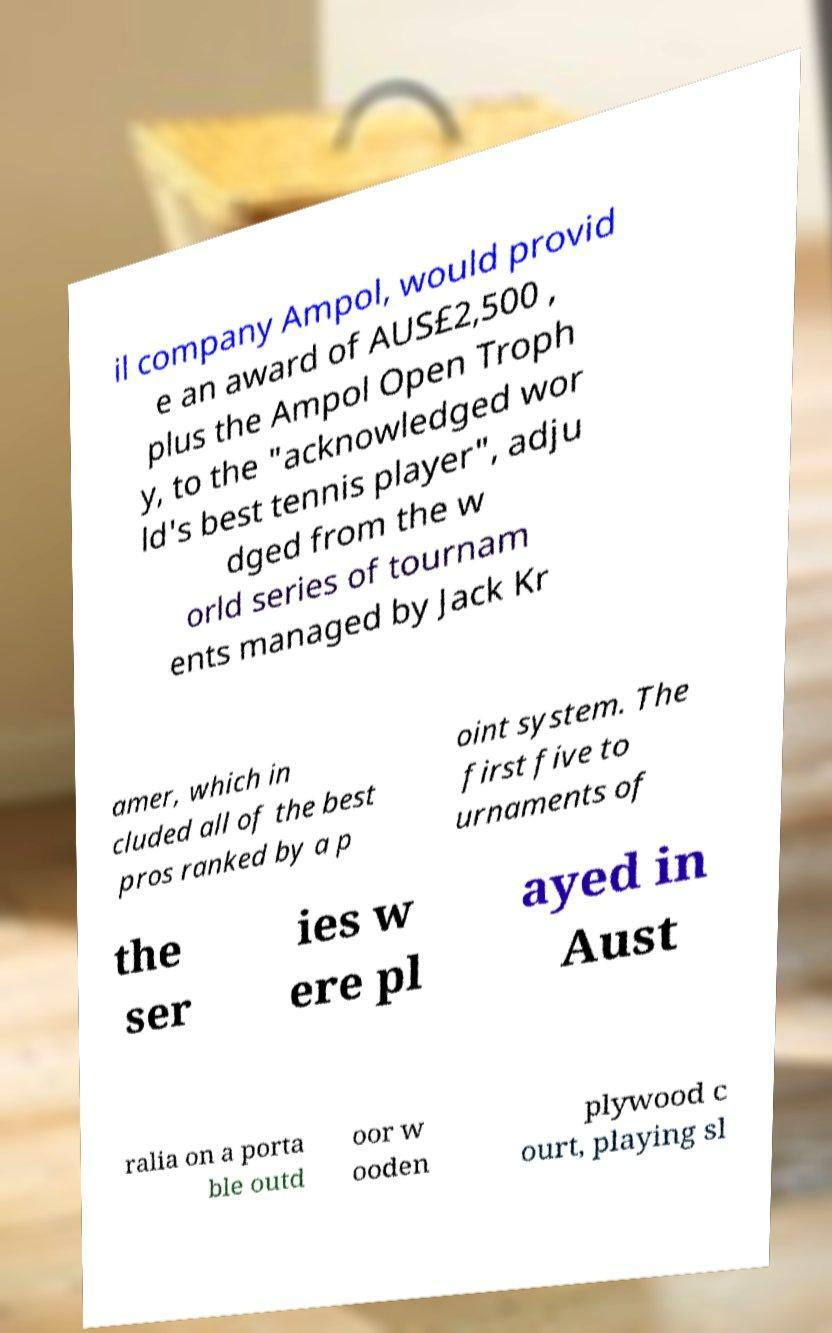For documentation purposes, I need the text within this image transcribed. Could you provide that? il company Ampol, would provid e an award of AUS£2,500 , plus the Ampol Open Troph y, to the "acknowledged wor ld's best tennis player", adju dged from the w orld series of tournam ents managed by Jack Kr amer, which in cluded all of the best pros ranked by a p oint system. The first five to urnaments of the ser ies w ere pl ayed in Aust ralia on a porta ble outd oor w ooden plywood c ourt, playing sl 